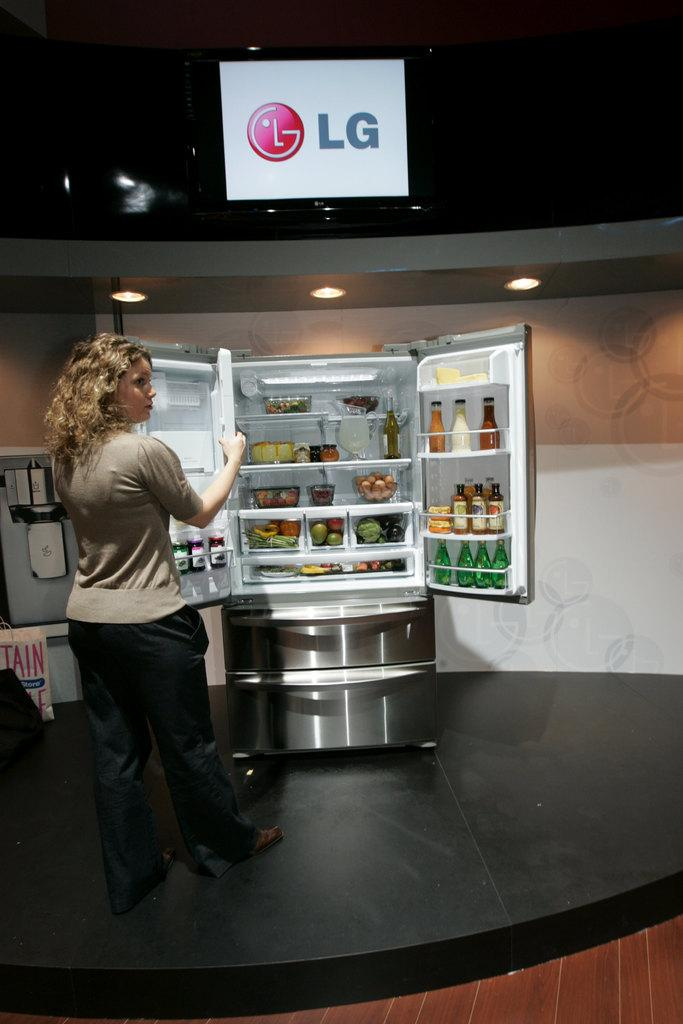<image>
Render a clear and concise summary of the photo. A woman opens a stainless steel LG brand refrigerator. 